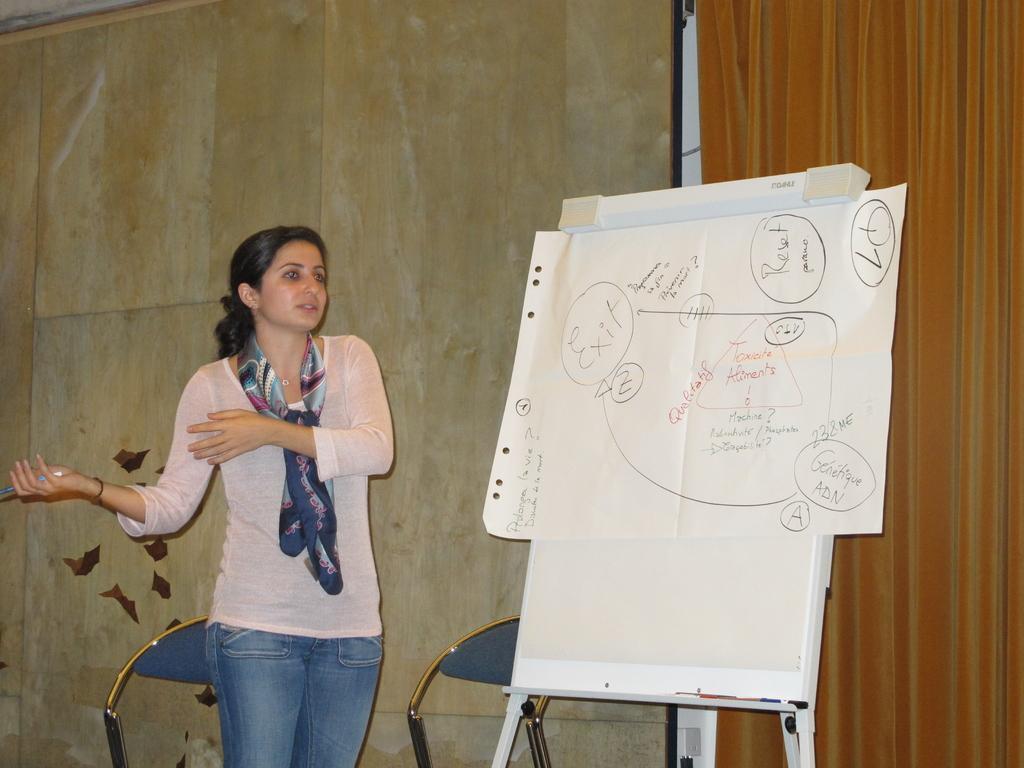In one or two sentences, can you explain what this image depicts? This image is taken indoors. In the background there is a wall and there are two empty chairs. On the left side of the image a woman is standing and she is holding a pen. In the middle of the image there is a board with a text on it. 